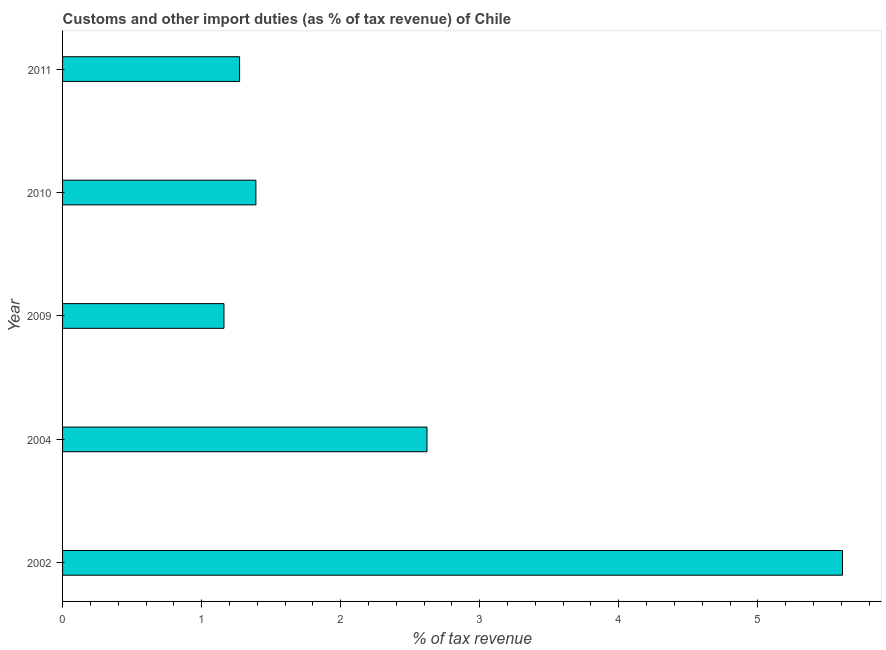What is the title of the graph?
Provide a succinct answer. Customs and other import duties (as % of tax revenue) of Chile. What is the label or title of the X-axis?
Offer a terse response. % of tax revenue. What is the label or title of the Y-axis?
Give a very brief answer. Year. What is the customs and other import duties in 2009?
Offer a very short reply. 1.16. Across all years, what is the maximum customs and other import duties?
Offer a terse response. 5.61. Across all years, what is the minimum customs and other import duties?
Your answer should be very brief. 1.16. In which year was the customs and other import duties maximum?
Your answer should be very brief. 2002. What is the sum of the customs and other import duties?
Keep it short and to the point. 12.05. What is the difference between the customs and other import duties in 2010 and 2011?
Provide a succinct answer. 0.12. What is the average customs and other import duties per year?
Provide a short and direct response. 2.41. What is the median customs and other import duties?
Provide a succinct answer. 1.39. What is the ratio of the customs and other import duties in 2002 to that in 2010?
Your response must be concise. 4.03. Is the customs and other import duties in 2004 less than that in 2011?
Give a very brief answer. No. Is the difference between the customs and other import duties in 2009 and 2011 greater than the difference between any two years?
Offer a very short reply. No. What is the difference between the highest and the second highest customs and other import duties?
Keep it short and to the point. 2.99. What is the difference between the highest and the lowest customs and other import duties?
Your answer should be compact. 4.45. In how many years, is the customs and other import duties greater than the average customs and other import duties taken over all years?
Offer a terse response. 2. Are the values on the major ticks of X-axis written in scientific E-notation?
Offer a terse response. No. What is the % of tax revenue of 2002?
Offer a terse response. 5.61. What is the % of tax revenue in 2004?
Offer a terse response. 2.62. What is the % of tax revenue in 2009?
Give a very brief answer. 1.16. What is the % of tax revenue of 2010?
Provide a succinct answer. 1.39. What is the % of tax revenue in 2011?
Your answer should be compact. 1.27. What is the difference between the % of tax revenue in 2002 and 2004?
Your answer should be compact. 2.99. What is the difference between the % of tax revenue in 2002 and 2009?
Provide a succinct answer. 4.45. What is the difference between the % of tax revenue in 2002 and 2010?
Give a very brief answer. 4.22. What is the difference between the % of tax revenue in 2002 and 2011?
Your response must be concise. 4.34. What is the difference between the % of tax revenue in 2004 and 2009?
Give a very brief answer. 1.46. What is the difference between the % of tax revenue in 2004 and 2010?
Give a very brief answer. 1.23. What is the difference between the % of tax revenue in 2004 and 2011?
Provide a short and direct response. 1.35. What is the difference between the % of tax revenue in 2009 and 2010?
Offer a very short reply. -0.23. What is the difference between the % of tax revenue in 2009 and 2011?
Offer a very short reply. -0.11. What is the difference between the % of tax revenue in 2010 and 2011?
Offer a very short reply. 0.12. What is the ratio of the % of tax revenue in 2002 to that in 2004?
Provide a short and direct response. 2.14. What is the ratio of the % of tax revenue in 2002 to that in 2009?
Keep it short and to the point. 4.83. What is the ratio of the % of tax revenue in 2002 to that in 2010?
Give a very brief answer. 4.03. What is the ratio of the % of tax revenue in 2002 to that in 2011?
Make the answer very short. 4.41. What is the ratio of the % of tax revenue in 2004 to that in 2009?
Offer a terse response. 2.26. What is the ratio of the % of tax revenue in 2004 to that in 2010?
Give a very brief answer. 1.89. What is the ratio of the % of tax revenue in 2004 to that in 2011?
Offer a very short reply. 2.06. What is the ratio of the % of tax revenue in 2009 to that in 2010?
Give a very brief answer. 0.83. What is the ratio of the % of tax revenue in 2009 to that in 2011?
Keep it short and to the point. 0.91. What is the ratio of the % of tax revenue in 2010 to that in 2011?
Offer a terse response. 1.09. 